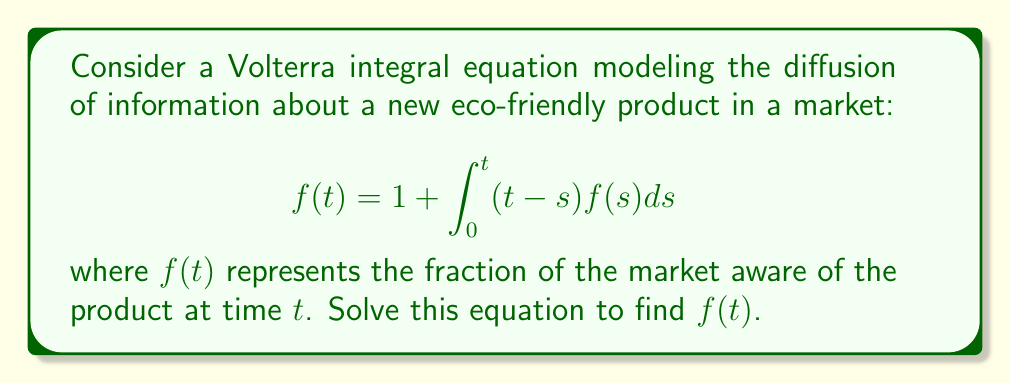Can you solve this math problem? To solve this Volterra integral equation, we'll follow these steps:

1) First, we recognize this as a Volterra equation of the second kind with kernel $K(t,s) = t-s$.

2) We'll use the method of Laplace transforms. Let $F(p)$ be the Laplace transform of $f(t)$.

3) Taking the Laplace transform of both sides:

   $$F(p) = \frac{1}{p} + \mathcal{L}\left\{\int_0^t (t-s)f(s)ds\right\}$$

4) Using the convolution theorem for Laplace transforms:

   $$F(p) = \frac{1}{p} + \frac{1}{p^2}F(p)$$

5) Rearranging the equation:

   $$F(p)\left(1 - \frac{1}{p^2}\right) = \frac{1}{p}$$

   $$F(p)\left(\frac{p^2-1}{p^2}\right) = \frac{1}{p}$$

6) Solving for $F(p)$:

   $$F(p) = \frac{p}{p^2-1}$$

7) This can be decomposed into partial fractions:

   $$F(p) = \frac{1}{2}\left(\frac{1}{p-1} + \frac{1}{p+1}\right)$$

8) Taking the inverse Laplace transform:

   $$f(t) = \frac{1}{2}(e^t + e^{-t})$$

9) This can be simplified using the definition of hyperbolic cosine:

   $$f(t) = \cosh(t)$$

This solution represents the fraction of the market aware of the product over time, showing an exponential growth pattern typical of information diffusion.
Answer: $f(t) = \cosh(t)$ 